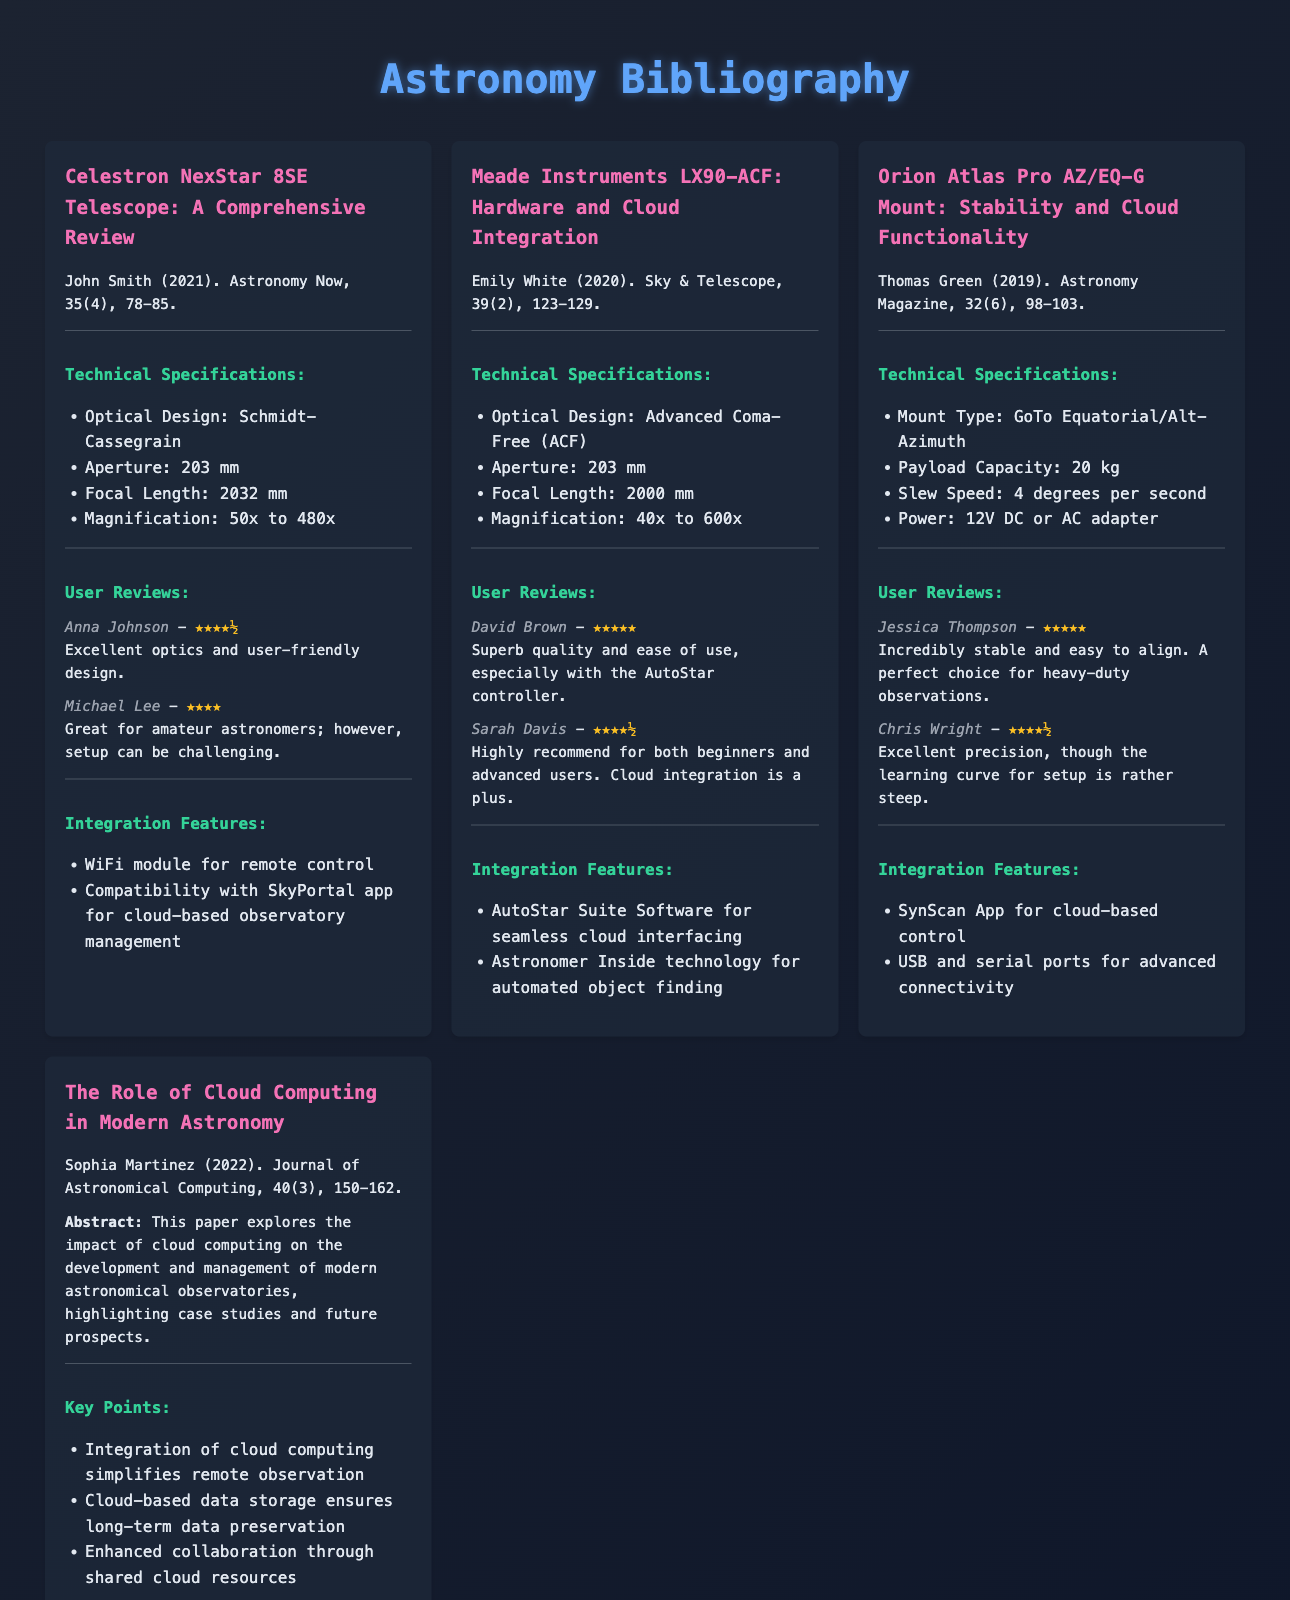What is the aperture size of the Celestron NexStar 8SE Telescope? The aperture size is mentioned in the technical specifications section of the document.
Answer: 203 mm Who authored the paper on the role of cloud computing in modern astronomy? The author is stated in the document under the corresponding entry.
Answer: Sophia Martinez What is the focal length of the Meade Instruments LX90-ACF? The focal length can be found in the technical specifications section of the Meade Instruments LX90-ACF entry.
Answer: 2000 mm What user rating did David Brown give to the Meade Instruments LX90-ACF? The user rating is found in the user reviews section of the document under David Brown's review.
Answer: ★★★★★ What integration feature is provided by the Orion Atlas Pro AZ/EQ-G Mount? Information regarding integration features is specified in the respective section for the mount in the document.
Answer: SynScan App for cloud-based control How many kilograms can the Orion Atlas Pro AZ/EQ-G Mount carry? The payload capacity is listed in the technical specifications of the entry.
Answer: 20 kg What is a key point regarding cloud computing as discussed in Sophia Martinez's paper? Key points are outlined in the integration section of the corresponding entry in the document.
Answer: Integration of cloud computing simplifies remote observation What is the magnification range for the Celestron NexStar 8SE Telescope? The magnification range is mentioned in the technical specifications of the telescope entry.
Answer: 50x to 480x What year was the review of the Orion Atlas Pro AZ/EQ-G Mount published? The publication year can be found in the entry's citation.
Answer: 2019 